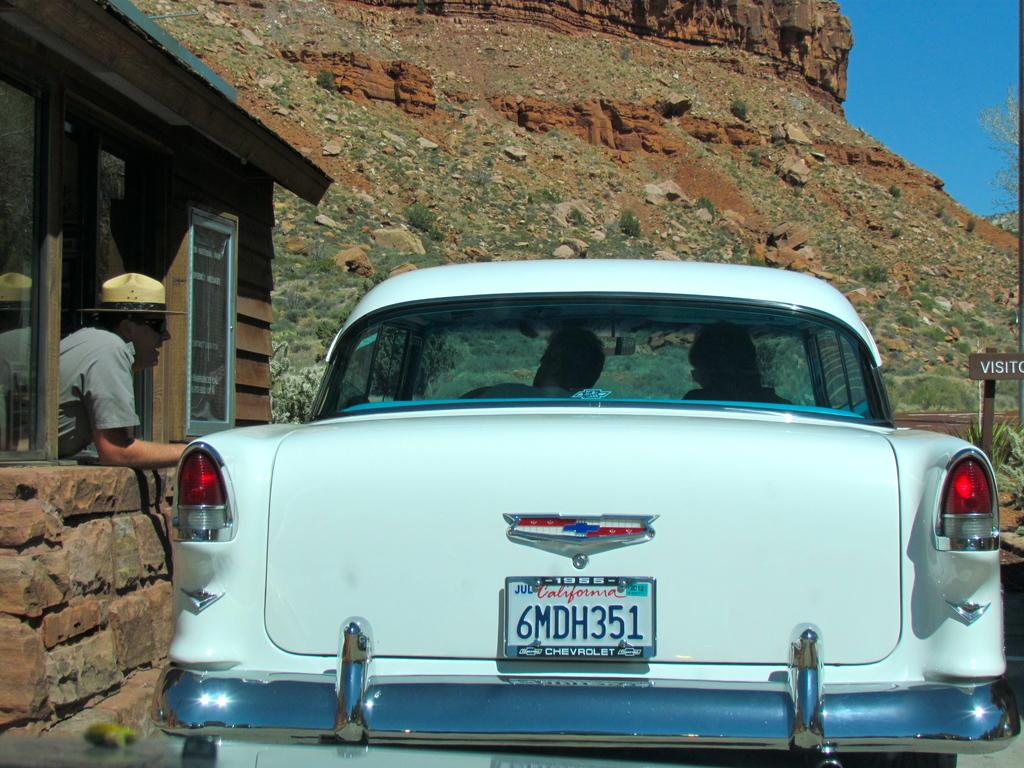What is the main subject in the center of the image? There is a car in the center of the image. What can be seen on the left side of the image? There is a cabinet on the left side of the image. What is unusual about the cabinet in the image? There is a man inside the cabinet. What can be seen in the background of the image? There is a sky and a hill visible in the background of the image. What disease is the man in the cabinet suffering from in the image? There is no indication of any disease in the image; it simply shows a man inside a cabinet. 